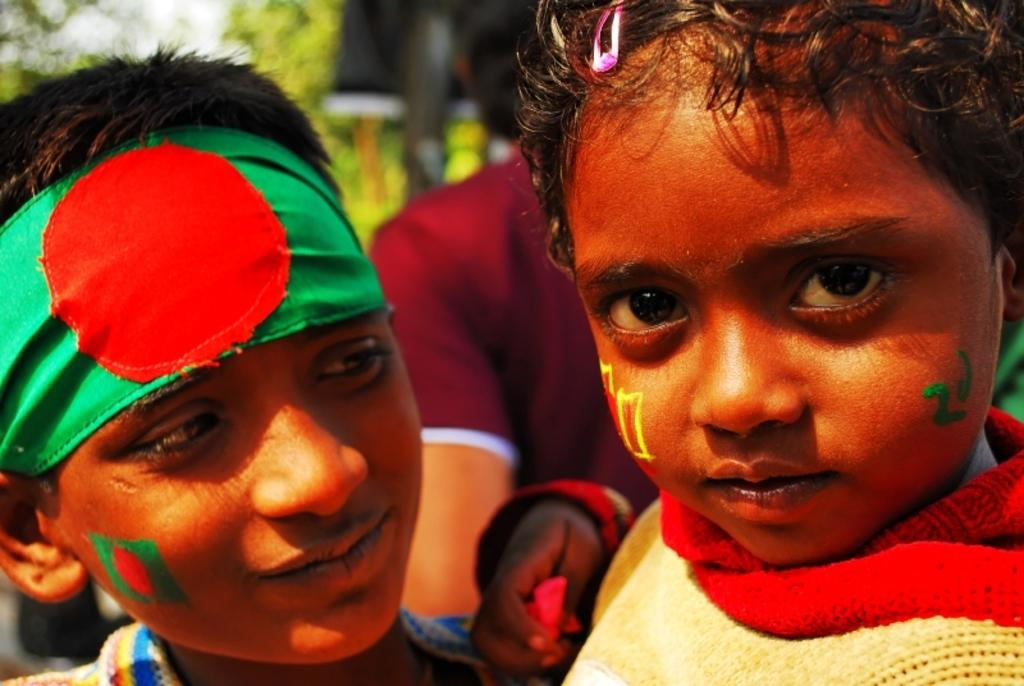What is the main subject in the foreground of the picture? There is a boy and a small kid in the foreground of the picture. Can you describe the background of the image? The background of the image is blurred. How far can the boy's stomach range in the image? There is no information about the boy's stomach in the image, so it cannot be determined how far it can range. 